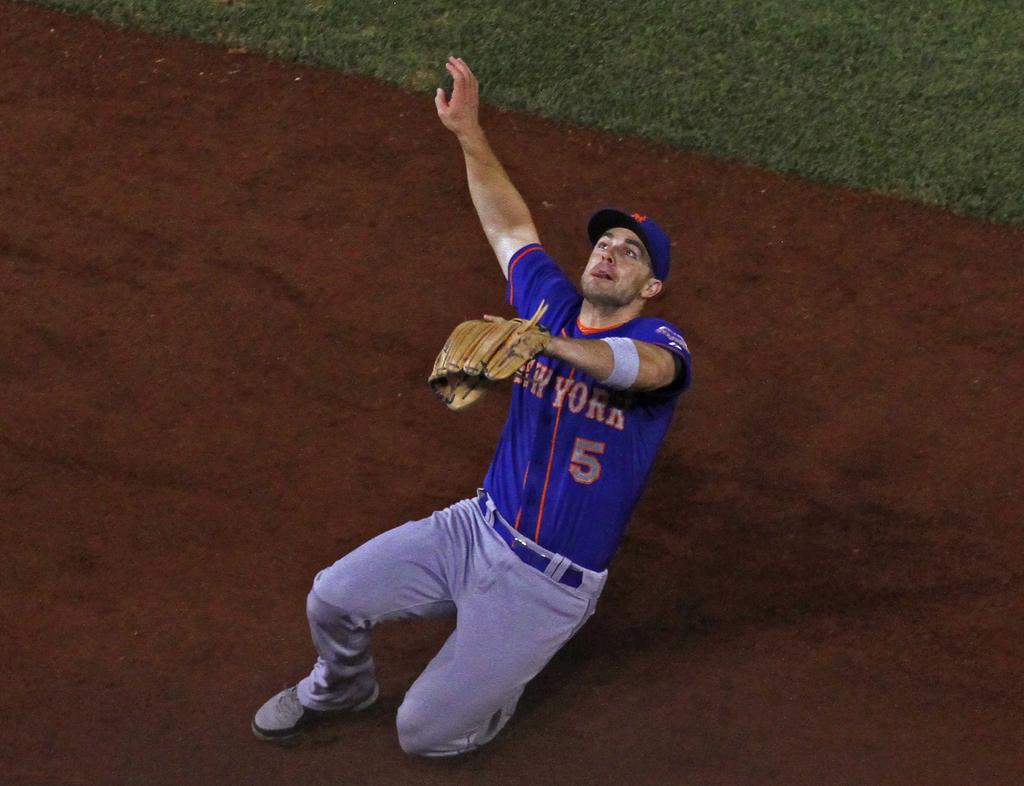<image>
Offer a succinct explanation of the picture presented. A baseball player wearing the number 5 has his arm up to catch the ball. 